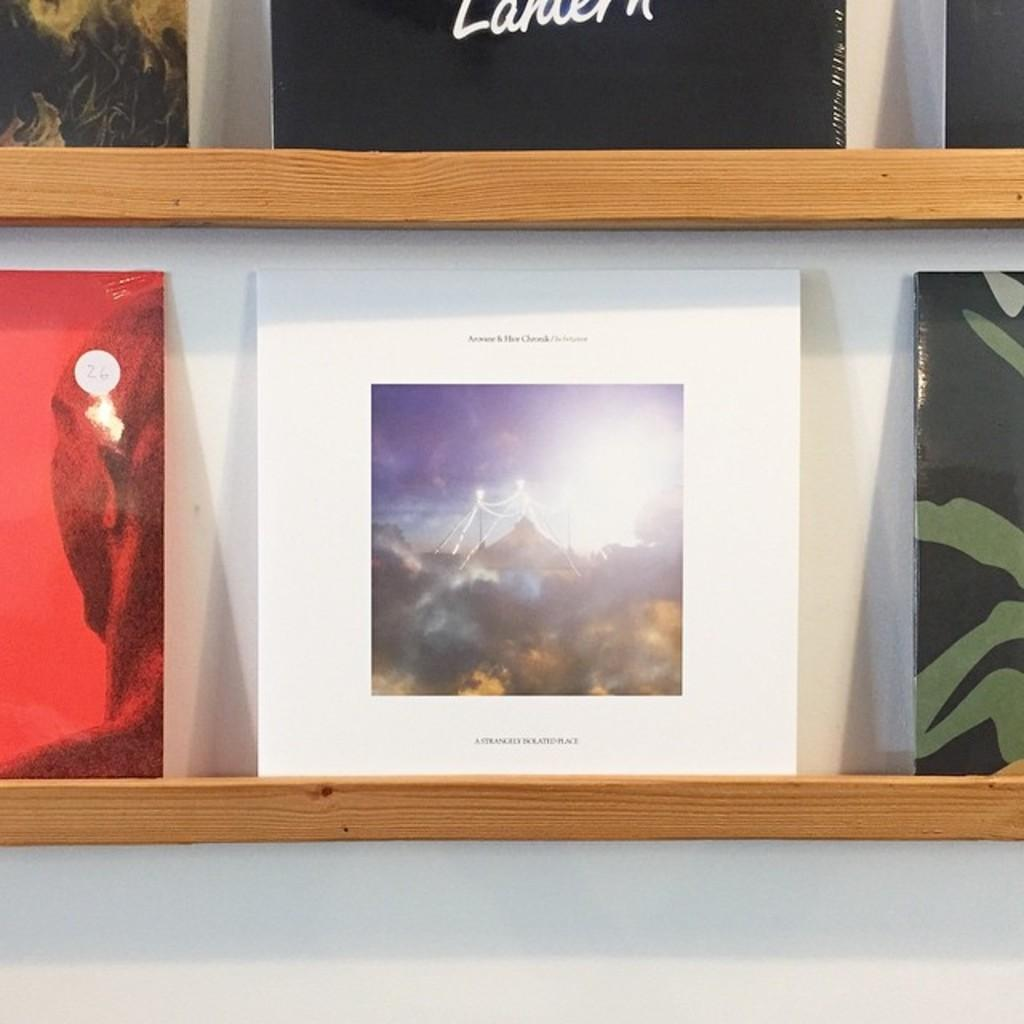<image>
Render a clear and concise summary of the photo. A photo with the caption A Strangely Isolated Place. 